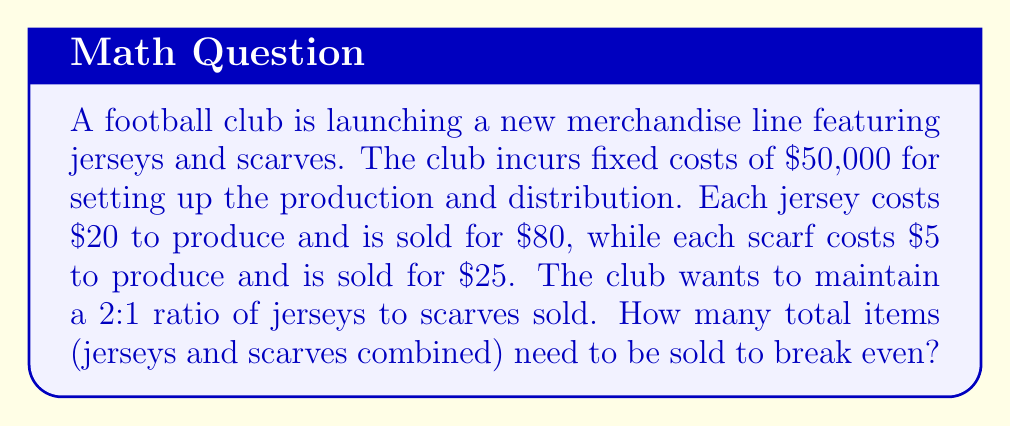Teach me how to tackle this problem. Let's approach this step-by-step:

1) Let $x$ be the number of jerseys sold and $y$ be the number of scarves sold.

2) Given the 2:1 ratio of jerseys to scarves, we can express this as an equation:
   $x = 2y$

3) The break-even point occurs when total revenue equals total costs:
   Revenue = Fixed Costs + Variable Costs

4) Let's express this equation using our variables:
   $80x + 25y = 50000 + 20x + 5y$

5) Simplify the equation:
   $60x + 20y = 50000$

6) Substitute $x = 2y$ into this equation:
   $60(2y) + 20y = 50000$
   $120y + 20y = 50000$
   $140y = 50000$

7) Solve for $y$:
   $y = \frac{50000}{140} = 357.14$

8) Since we can't sell partial items, we round up to 358 scarves.

9) Calculate the number of jerseys:
   $x = 2y = 2(358) = 716$

10) The total number of items is the sum of jerseys and scarves:
    $716 + 358 = 1074$

Therefore, the club needs to sell 1074 items to break even.
Answer: 1074 items 